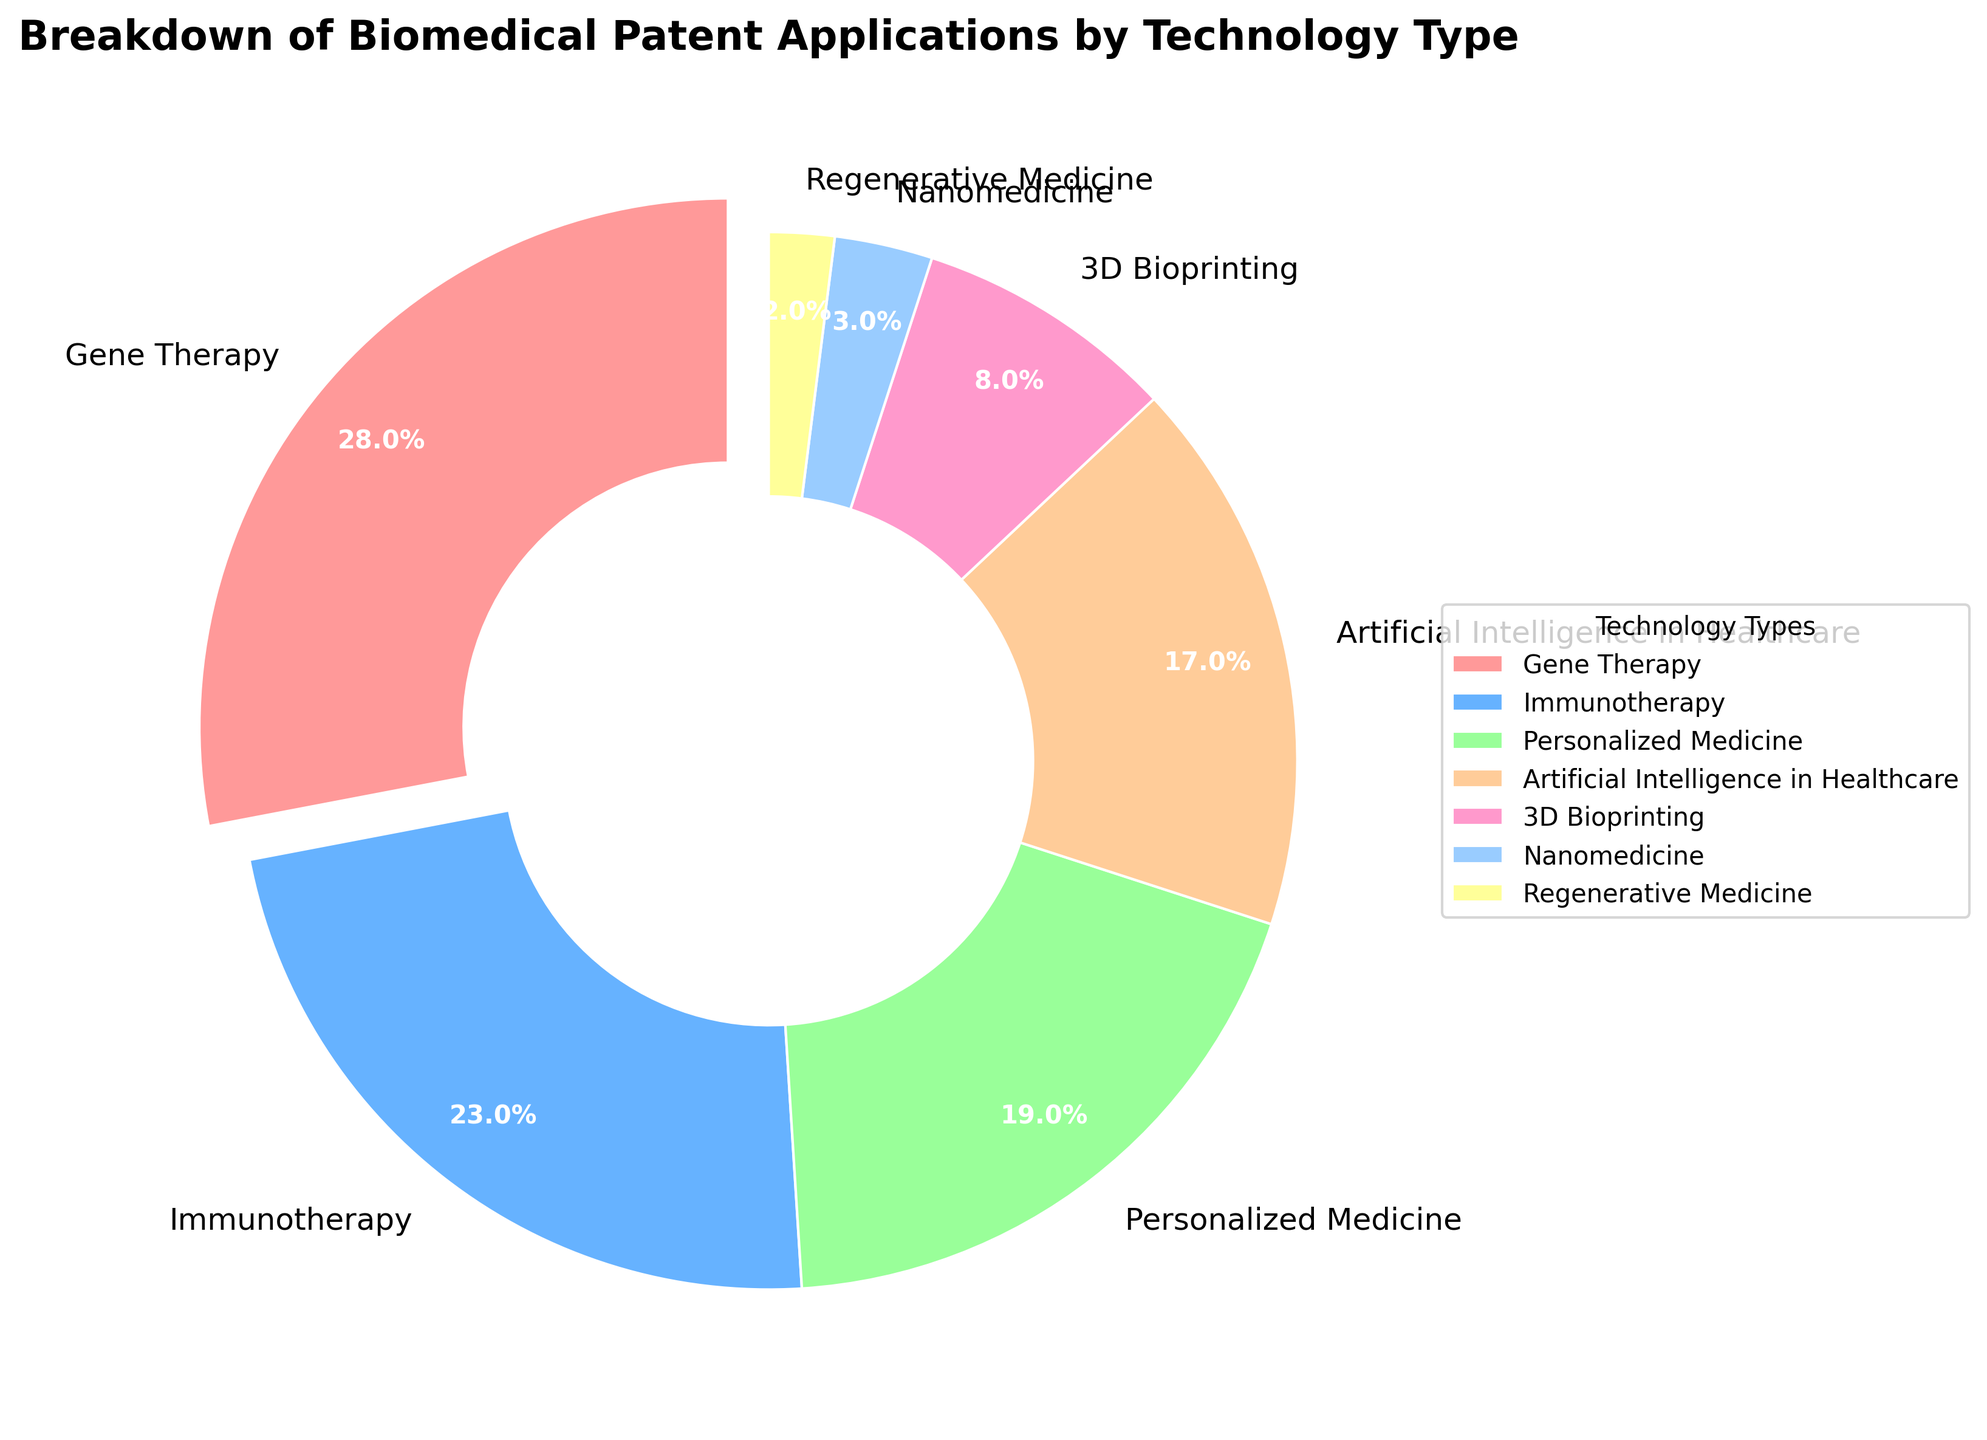What's the technology category with the largest percentage of biomedical patent applications? Gene Therapy has the largest slice of the pie chart.
Answer: Gene Therapy Which technology type has a larger percentage of applications: Personalized Medicine or Artificial Intelligence in Healthcare? Personalized Medicine has a larger slice at 19%, compared to Artificial Intelligence in Healthcare at 17%.
Answer: Personalized Medicine Which three technology types have the least percentage of patent applications combined? Adding the percentages for 3D Bioprinting (8%), Nanomedicine (3%), and Regenerative Medicine (2%) gives 8 + 3 + 2 = 13%.
Answer: 3D Bioprinting, Nanomedicine, and Regenerative Medicine How does the percentage of Immunotherapy patent applications compare to that of Gene Therapy? Immunotherapy has a 23% share, which is less than Gene Therapy at 28%.
Answer: Less than What is the visual attribute distinguishing the largest technology slice on the pie chart? The largest slice, representing Gene Therapy, is separated slightly from the rest of the pie chart.
Answer: It's exploded from the pie chart What's the difference in the percentage of patent applications between the technology types with the largest and smallest slices? Subtracting the smallest slice (Regenerative Medicine at 2%) from the largest slice (Gene Therapy at 28%) gives 28 - 2 = 26%.
Answer: 26% Which color represents the technology type with the second largest percentage of applications? The second largest slice is Immunotherapy at 23%, represented by a light blue color.
Answer: Light Blue How many technology types have more than a 20% share of biomedical patent applications? Only two technology types (Gene Therapy at 28% and Immunotherapy at 23%) have more than a 20% share.
Answer: Two What's the total percentage for categories other than the two most significant technology types (Gene Therapy and Immunotherapy)? Summing the percentages for Personalized Medicine (19%), Artificial Intelligence in Healthcare (17%), 3D Bioprinting (8%), Nanomedicine (3%), and Regenerative Medicine (2%) gives 19 + 17 + 8 + 3 + 2 = 49%.
Answer: 49% Which technology type, represented by green, has what percentage of patent applications? The green color represents Artificial Intelligence in Healthcare, which has 17% of the patent applications.
Answer: Artificial Intelligence in Healthcare (17%) 